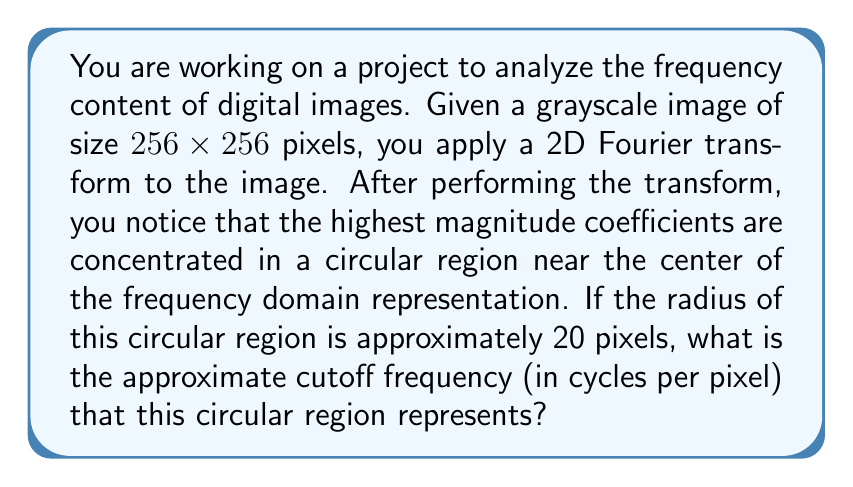Could you help me with this problem? To solve this problem, we need to understand the relationship between the spatial domain of the image and its frequency domain representation after applying the 2D Fourier transform. Let's break it down step by step:

1. The size of the image is 256x256 pixels. In the frequency domain, this corresponds to a 256x256 grid of frequency components.

2. In the frequency domain, the center of the image (at coordinates (128, 128)) represents the DC component (zero frequency).

3. The edges of the frequency domain represent the highest frequencies. The maximum frequency in cycles per pixel is 0.5, which occurs at the edges of the frequency domain.

4. The relationship between pixel distance from the center and frequency is linear. We can set up the following proportion:

   $$\frac{\text{pixel distance}}{\text{half image width}} = \frac{\text{frequency}}{0.5 \text{ cycles/pixel}}$$

5. In this case, the pixel distance is the radius of the circular region, which is 20 pixels. The half image width is 128 pixels.

6. Substituting these values into our proportion:

   $$\frac{20}{128} = \frac{f}{0.5}$$

7. Solving for $f$ (the cutoff frequency):

   $$f = 0.5 \cdot \frac{20}{128} = \frac{10}{128} \approx 0.078125 \text{ cycles/pixel}$$

Therefore, the circular region with a radius of 20 pixels in the frequency domain represents a cutoff frequency of approximately 0.078125 cycles per pixel.
Answer: The approximate cutoff frequency is 0.078125 cycles per pixel. 